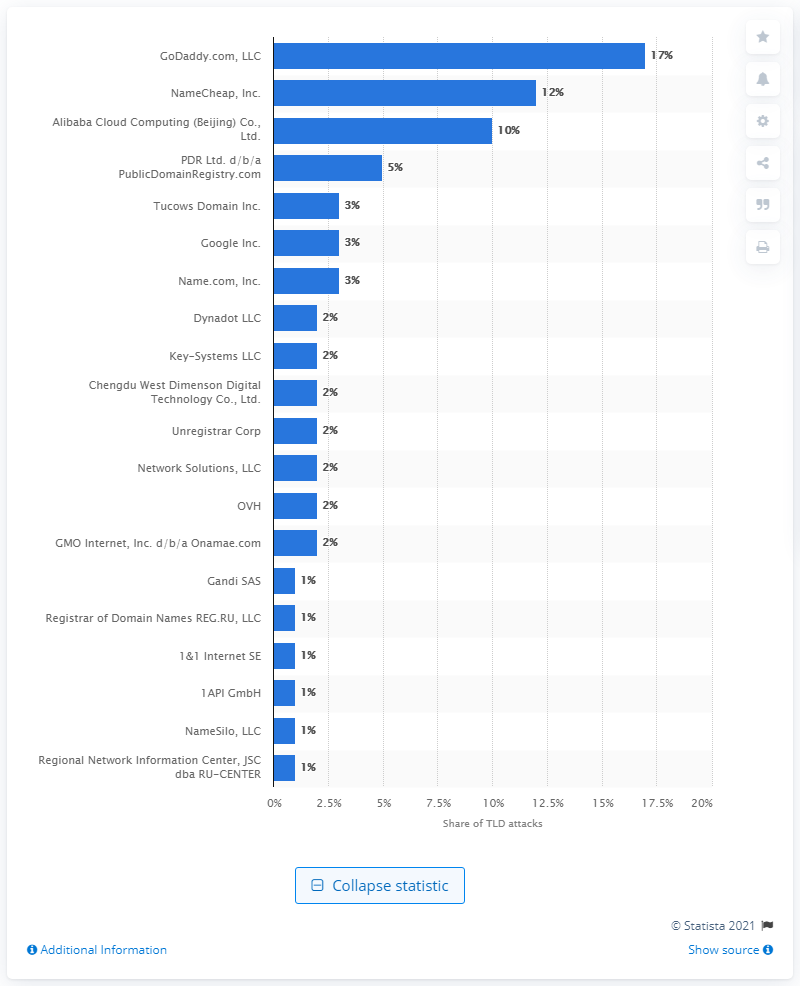List a handful of essential elements in this visual. In 2018, GoDaddy.com, LLC was the registrar with the highest share of top-level domain attacks. 